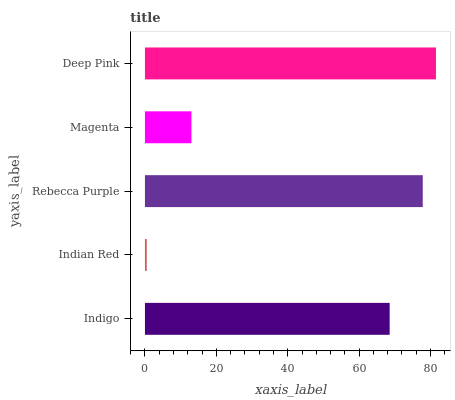Is Indian Red the minimum?
Answer yes or no. Yes. Is Deep Pink the maximum?
Answer yes or no. Yes. Is Rebecca Purple the minimum?
Answer yes or no. No. Is Rebecca Purple the maximum?
Answer yes or no. No. Is Rebecca Purple greater than Indian Red?
Answer yes or no. Yes. Is Indian Red less than Rebecca Purple?
Answer yes or no. Yes. Is Indian Red greater than Rebecca Purple?
Answer yes or no. No. Is Rebecca Purple less than Indian Red?
Answer yes or no. No. Is Indigo the high median?
Answer yes or no. Yes. Is Indigo the low median?
Answer yes or no. Yes. Is Rebecca Purple the high median?
Answer yes or no. No. Is Rebecca Purple the low median?
Answer yes or no. No. 